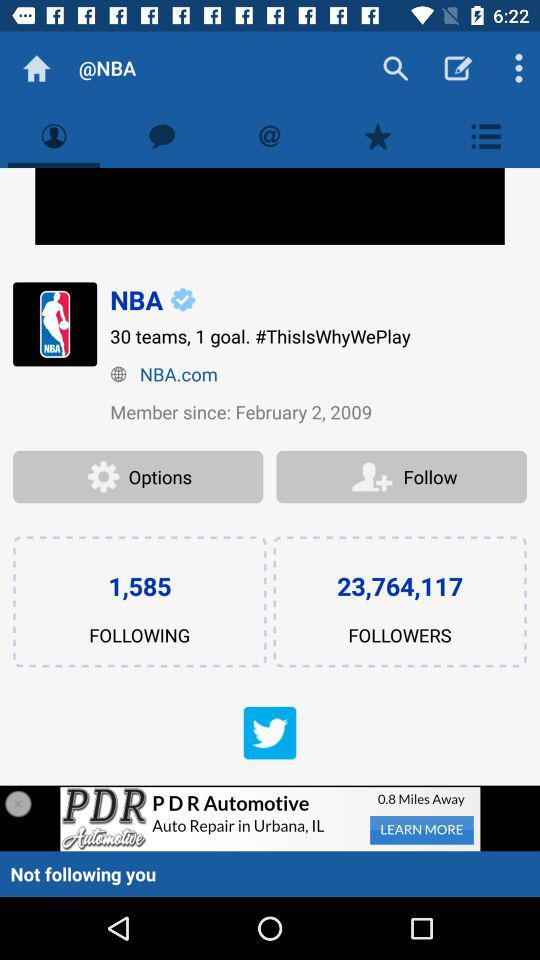How many followers are there? There are 23,764,117 followers. 